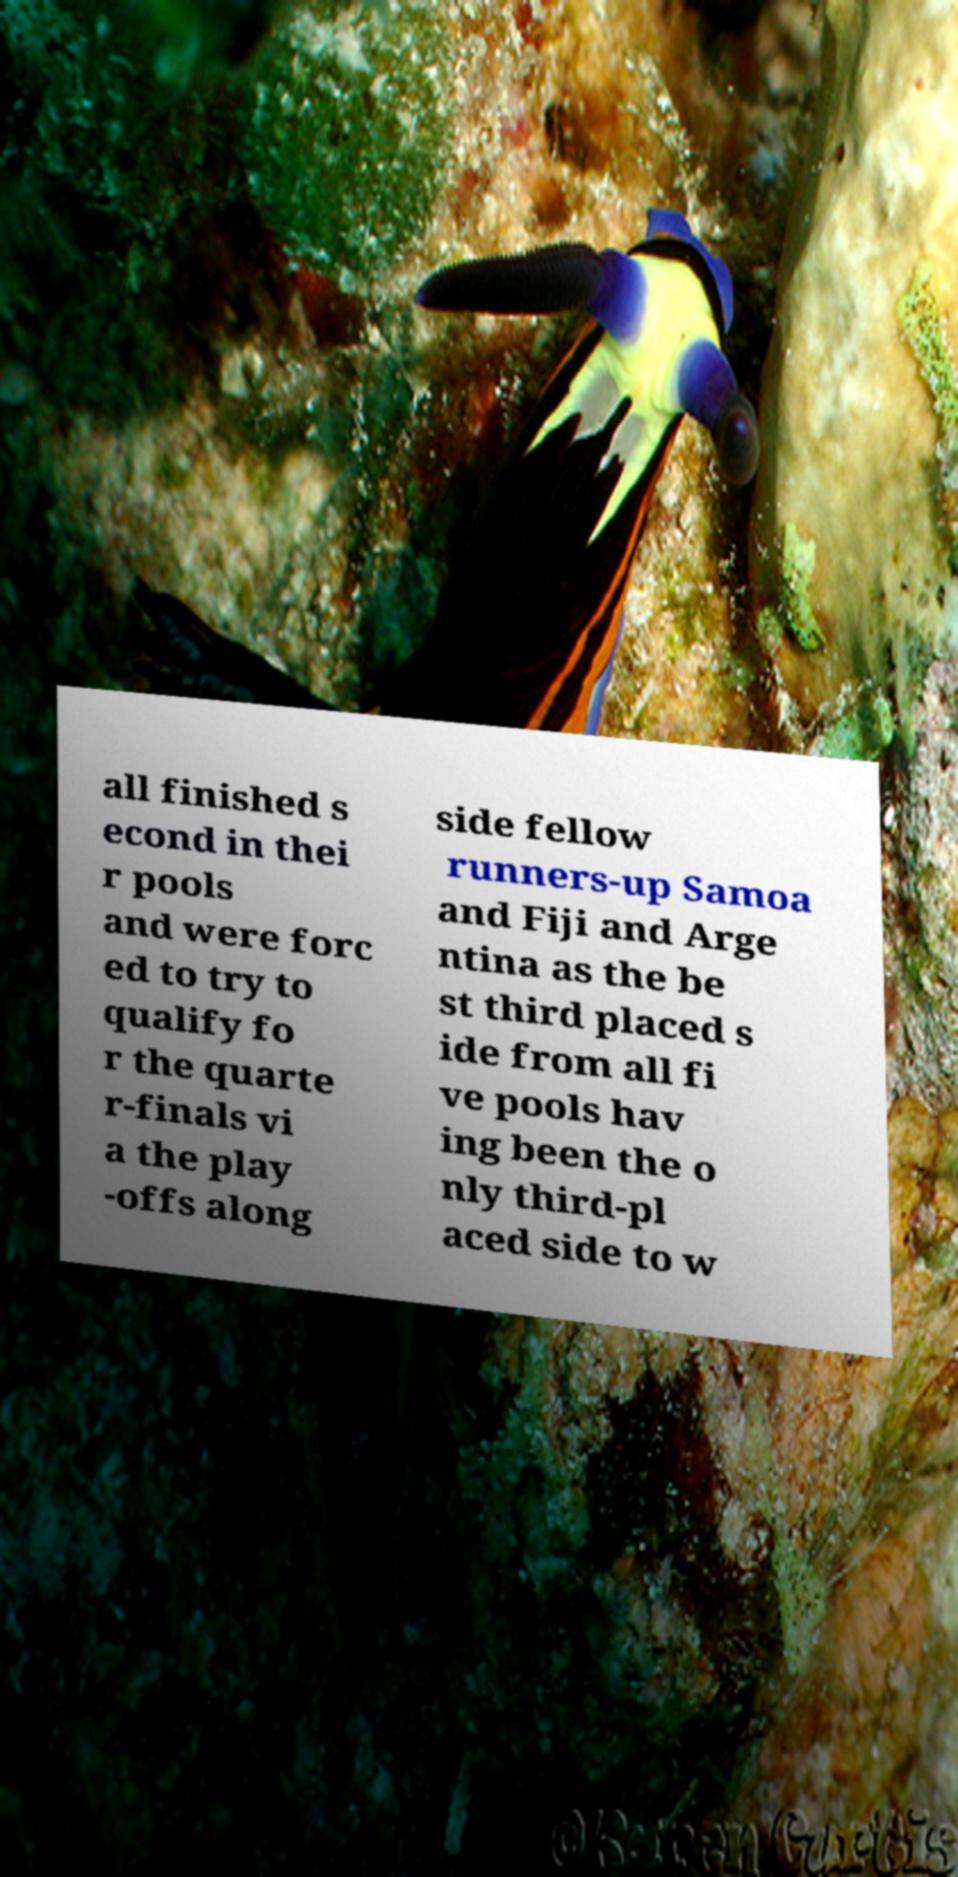What messages or text are displayed in this image? I need them in a readable, typed format. all finished s econd in thei r pools and were forc ed to try to qualify fo r the quarte r-finals vi a the play -offs along side fellow runners-up Samoa and Fiji and Arge ntina as the be st third placed s ide from all fi ve pools hav ing been the o nly third-pl aced side to w 